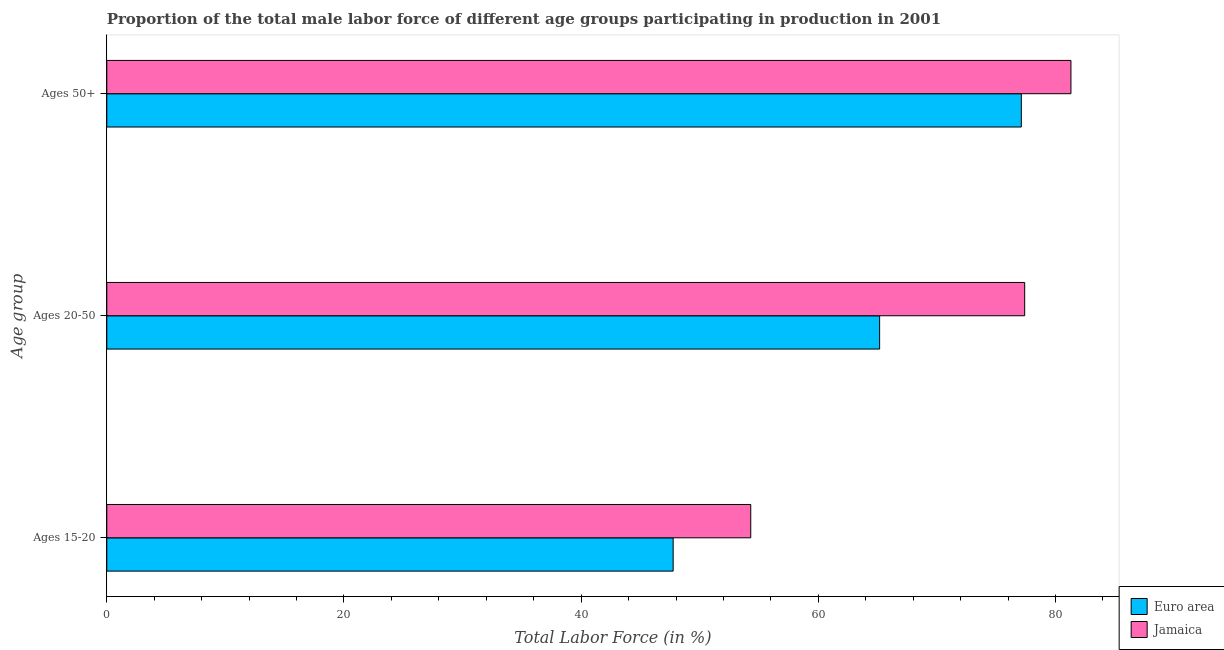How many different coloured bars are there?
Provide a succinct answer. 2. How many groups of bars are there?
Your response must be concise. 3. Are the number of bars per tick equal to the number of legend labels?
Keep it short and to the point. Yes. How many bars are there on the 1st tick from the bottom?
Offer a very short reply. 2. What is the label of the 2nd group of bars from the top?
Your answer should be very brief. Ages 20-50. What is the percentage of male labor force above age 50 in Euro area?
Give a very brief answer. 77.12. Across all countries, what is the maximum percentage of male labor force within the age group 20-50?
Your answer should be very brief. 77.4. Across all countries, what is the minimum percentage of male labor force above age 50?
Offer a very short reply. 77.12. In which country was the percentage of male labor force within the age group 20-50 maximum?
Ensure brevity in your answer.  Jamaica. What is the total percentage of male labor force within the age group 15-20 in the graph?
Make the answer very short. 102.06. What is the difference between the percentage of male labor force above age 50 in Jamaica and that in Euro area?
Your answer should be very brief. 4.18. What is the difference between the percentage of male labor force within the age group 20-50 in Jamaica and the percentage of male labor force within the age group 15-20 in Euro area?
Make the answer very short. 29.64. What is the average percentage of male labor force above age 50 per country?
Ensure brevity in your answer.  79.21. What is the difference between the percentage of male labor force within the age group 20-50 and percentage of male labor force within the age group 15-20 in Euro area?
Keep it short and to the point. 17.41. In how many countries, is the percentage of male labor force within the age group 20-50 greater than 12 %?
Your response must be concise. 2. What is the ratio of the percentage of male labor force within the age group 15-20 in Euro area to that in Jamaica?
Offer a very short reply. 0.88. Is the percentage of male labor force within the age group 15-20 in Euro area less than that in Jamaica?
Your answer should be compact. Yes. What is the difference between the highest and the second highest percentage of male labor force above age 50?
Your response must be concise. 4.18. What is the difference between the highest and the lowest percentage of male labor force above age 50?
Provide a short and direct response. 4.18. In how many countries, is the percentage of male labor force within the age group 20-50 greater than the average percentage of male labor force within the age group 20-50 taken over all countries?
Make the answer very short. 1. What does the 1st bar from the top in Ages 50+ represents?
Your response must be concise. Jamaica. What does the 2nd bar from the bottom in Ages 50+ represents?
Offer a very short reply. Jamaica. Is it the case that in every country, the sum of the percentage of male labor force within the age group 15-20 and percentage of male labor force within the age group 20-50 is greater than the percentage of male labor force above age 50?
Your response must be concise. Yes. How many bars are there?
Ensure brevity in your answer.  6. Are all the bars in the graph horizontal?
Provide a short and direct response. Yes. How many countries are there in the graph?
Offer a terse response. 2. What is the difference between two consecutive major ticks on the X-axis?
Your answer should be very brief. 20. Are the values on the major ticks of X-axis written in scientific E-notation?
Make the answer very short. No. How are the legend labels stacked?
Provide a short and direct response. Vertical. What is the title of the graph?
Offer a terse response. Proportion of the total male labor force of different age groups participating in production in 2001. Does "Aruba" appear as one of the legend labels in the graph?
Provide a short and direct response. No. What is the label or title of the Y-axis?
Your response must be concise. Age group. What is the Total Labor Force (in %) in Euro area in Ages 15-20?
Provide a short and direct response. 47.76. What is the Total Labor Force (in %) in Jamaica in Ages 15-20?
Provide a succinct answer. 54.3. What is the Total Labor Force (in %) in Euro area in Ages 20-50?
Ensure brevity in your answer.  65.17. What is the Total Labor Force (in %) in Jamaica in Ages 20-50?
Make the answer very short. 77.4. What is the Total Labor Force (in %) in Euro area in Ages 50+?
Your answer should be very brief. 77.12. What is the Total Labor Force (in %) of Jamaica in Ages 50+?
Offer a terse response. 81.3. Across all Age group, what is the maximum Total Labor Force (in %) in Euro area?
Make the answer very short. 77.12. Across all Age group, what is the maximum Total Labor Force (in %) of Jamaica?
Give a very brief answer. 81.3. Across all Age group, what is the minimum Total Labor Force (in %) in Euro area?
Your response must be concise. 47.76. Across all Age group, what is the minimum Total Labor Force (in %) in Jamaica?
Make the answer very short. 54.3. What is the total Total Labor Force (in %) of Euro area in the graph?
Give a very brief answer. 190.04. What is the total Total Labor Force (in %) of Jamaica in the graph?
Your response must be concise. 213. What is the difference between the Total Labor Force (in %) of Euro area in Ages 15-20 and that in Ages 20-50?
Your response must be concise. -17.41. What is the difference between the Total Labor Force (in %) in Jamaica in Ages 15-20 and that in Ages 20-50?
Keep it short and to the point. -23.1. What is the difference between the Total Labor Force (in %) of Euro area in Ages 15-20 and that in Ages 50+?
Your response must be concise. -29.36. What is the difference between the Total Labor Force (in %) of Jamaica in Ages 15-20 and that in Ages 50+?
Give a very brief answer. -27. What is the difference between the Total Labor Force (in %) in Euro area in Ages 20-50 and that in Ages 50+?
Provide a succinct answer. -11.95. What is the difference between the Total Labor Force (in %) in Euro area in Ages 15-20 and the Total Labor Force (in %) in Jamaica in Ages 20-50?
Your answer should be very brief. -29.64. What is the difference between the Total Labor Force (in %) in Euro area in Ages 15-20 and the Total Labor Force (in %) in Jamaica in Ages 50+?
Keep it short and to the point. -33.54. What is the difference between the Total Labor Force (in %) of Euro area in Ages 20-50 and the Total Labor Force (in %) of Jamaica in Ages 50+?
Your answer should be compact. -16.13. What is the average Total Labor Force (in %) of Euro area per Age group?
Offer a terse response. 63.35. What is the average Total Labor Force (in %) in Jamaica per Age group?
Your answer should be compact. 71. What is the difference between the Total Labor Force (in %) in Euro area and Total Labor Force (in %) in Jamaica in Ages 15-20?
Offer a very short reply. -6.54. What is the difference between the Total Labor Force (in %) in Euro area and Total Labor Force (in %) in Jamaica in Ages 20-50?
Offer a terse response. -12.23. What is the difference between the Total Labor Force (in %) in Euro area and Total Labor Force (in %) in Jamaica in Ages 50+?
Offer a terse response. -4.18. What is the ratio of the Total Labor Force (in %) of Euro area in Ages 15-20 to that in Ages 20-50?
Make the answer very short. 0.73. What is the ratio of the Total Labor Force (in %) in Jamaica in Ages 15-20 to that in Ages 20-50?
Give a very brief answer. 0.7. What is the ratio of the Total Labor Force (in %) of Euro area in Ages 15-20 to that in Ages 50+?
Your answer should be compact. 0.62. What is the ratio of the Total Labor Force (in %) in Jamaica in Ages 15-20 to that in Ages 50+?
Your answer should be very brief. 0.67. What is the ratio of the Total Labor Force (in %) of Euro area in Ages 20-50 to that in Ages 50+?
Make the answer very short. 0.85. What is the ratio of the Total Labor Force (in %) of Jamaica in Ages 20-50 to that in Ages 50+?
Make the answer very short. 0.95. What is the difference between the highest and the second highest Total Labor Force (in %) in Euro area?
Offer a terse response. 11.95. What is the difference between the highest and the lowest Total Labor Force (in %) of Euro area?
Ensure brevity in your answer.  29.36. 